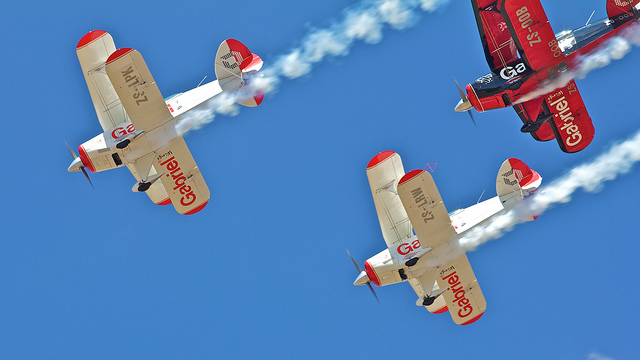Can you tell me more about the details on these planes? Certainly! Each plane has a distinct bright red or cream-colored livery with sponsor logos and markings. They exhibit large rounded wingtips and fixed landing gear, which are indicative of their vintage design. The presence of multiple ailerons on both the upper and lower wings also suggests they are designed for maneuverability during complex aerobatic routines. What might be the significance of the color schemes? The color schemes serve multiple purposes: they enhance the aesthetic appeal of the aircraft, increase their visibility against the sky during performances, and provide a means for sponsors to display their branding, which is often crucial for funding these airshows. 